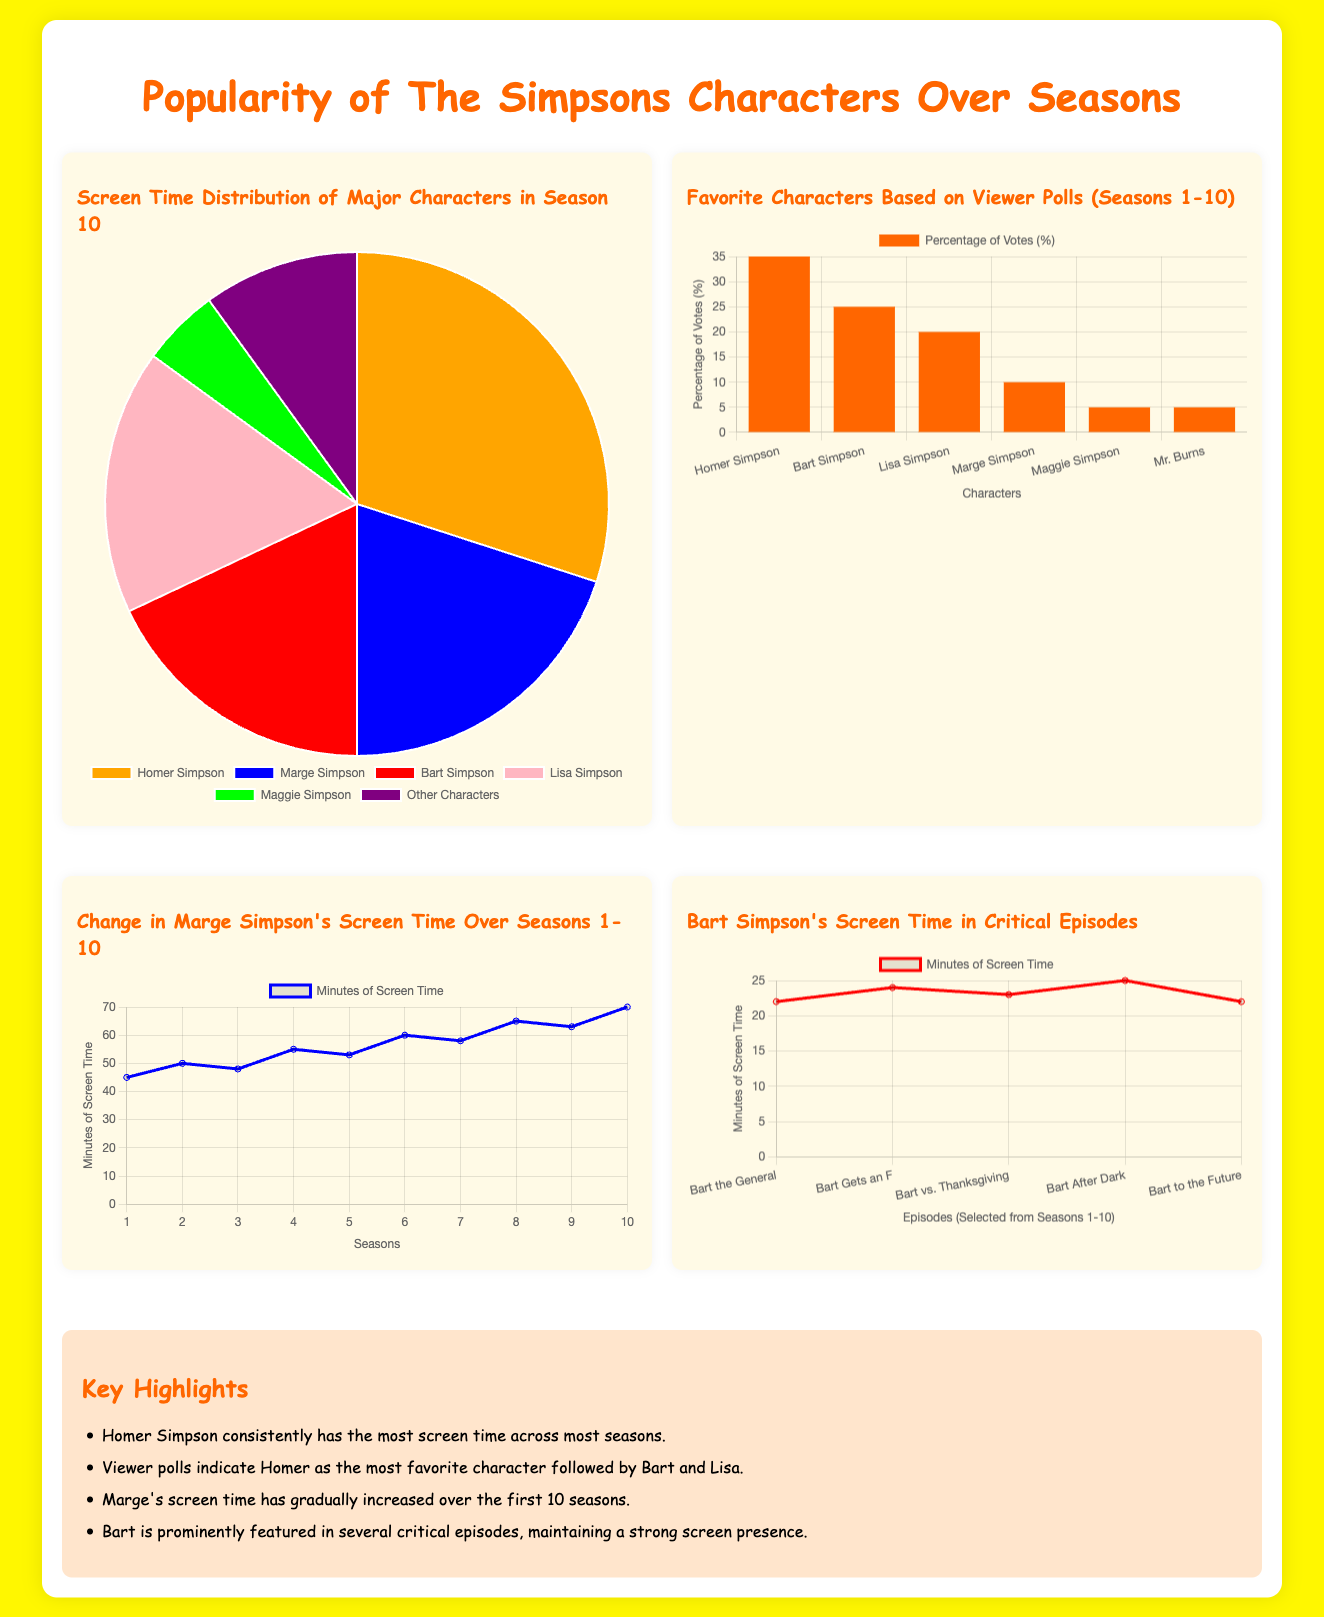What character has the highest screen time in Season 10? The pie chart shows that Homer Simpson has the highest screen time distribution in Season 10 at 30%.
Answer: Homer Simpson What percentage of viewers voted for Bart Simpson as their favorite character? The bar graph indicates that Bart Simpson received 25% of the votes in viewer polls.
Answer: 25% How many minutes of screen time did Marge Simpsons have in Season 10? The line chart for Marge's screen time shows that she had 70 minutes in Season 10.
Answer: 70 What is the minimum screen time Bart Simpson had in critical episodes? The line chart for Bart shows that his minimum screen time in the selected critical episodes is 22 minutes.
Answer: 22 How much screen time did Marge Simpson accumulate over the first 10 seasons? The line chart indicates Marge Simpson's screen time increased from 45 minutes to 70 minutes over the first 10 seasons.
Answer: From 45 to 70 minutes Which character is represented as "Other Characters" in the pie chart? The pie chart lists "Other Characters" as a category, which includes characters other than the main five.
Answer: Other Characters 